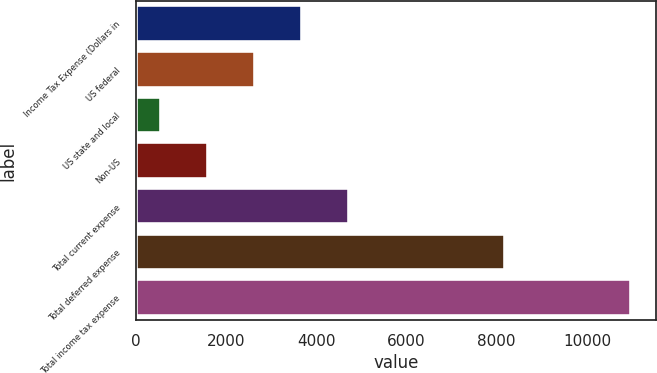Convert chart. <chart><loc_0><loc_0><loc_500><loc_500><bar_chart><fcel>Income Tax Expense (Dollars in<fcel>US federal<fcel>US state and local<fcel>Non-US<fcel>Total current expense<fcel>Total deferred expense<fcel>Total income tax expense<nl><fcel>3684.2<fcel>2641.8<fcel>557<fcel>1599.4<fcel>4726.6<fcel>8175<fcel>10981<nl></chart> 